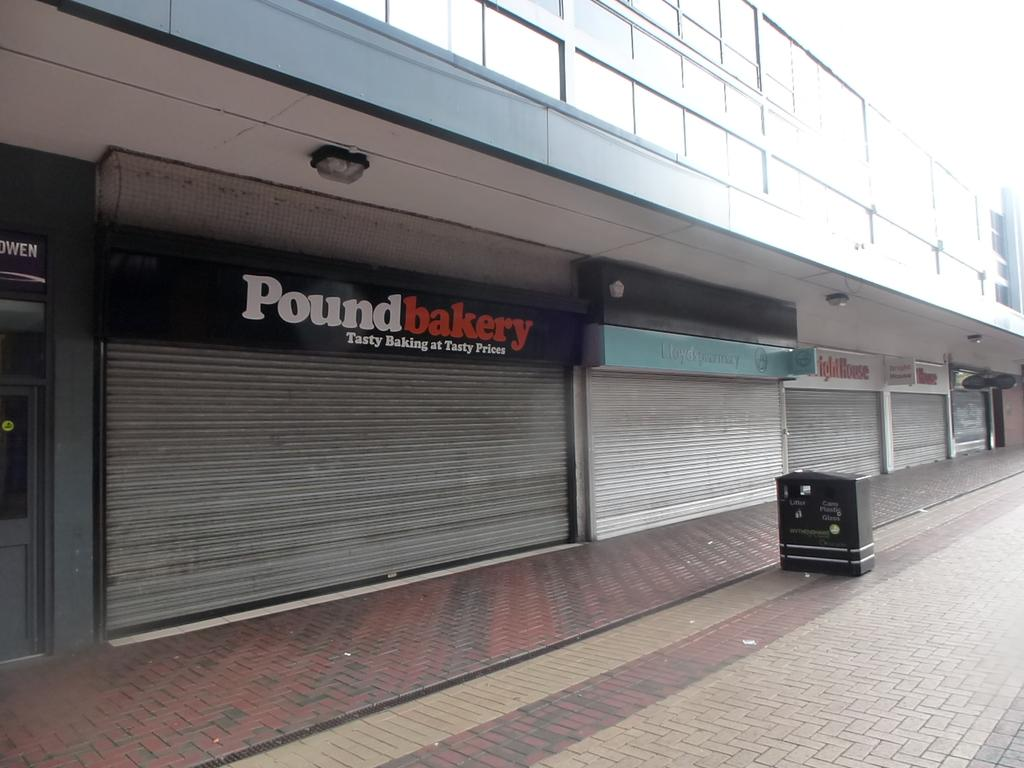<image>
Write a terse but informative summary of the picture. A store front for Pound Bakery is closed 